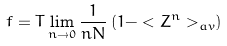<formula> <loc_0><loc_0><loc_500><loc_500>f = T \lim _ { n \to 0 } \frac { 1 } { n N } \left ( 1 - < Z ^ { n } > _ { a v } \right )</formula> 